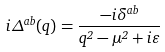Convert formula to latex. <formula><loc_0><loc_0><loc_500><loc_500>i \Delta ^ { a b } ( q ) = \frac { - i \delta ^ { a b } } { q ^ { 2 } - \mu ^ { 2 } + i \varepsilon }</formula> 